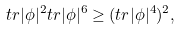Convert formula to latex. <formula><loc_0><loc_0><loc_500><loc_500>t r | \phi | ^ { 2 } t r | \phi | ^ { 6 } \geq ( t r | \phi | ^ { 4 } ) ^ { 2 } ,</formula> 